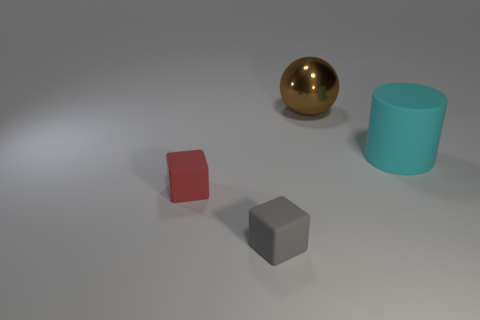Subtract all red blocks. How many blocks are left? 1 Subtract 1 cylinders. How many cylinders are left? 0 Subtract all red blocks. How many red cylinders are left? 0 Add 2 cyan rubber cylinders. How many cyan rubber cylinders are left? 3 Add 3 tiny gray rubber blocks. How many tiny gray rubber blocks exist? 4 Add 4 brown balls. How many objects exist? 8 Subtract 1 gray cubes. How many objects are left? 3 Subtract all purple cubes. Subtract all gray spheres. How many cubes are left? 2 Subtract all large cylinders. Subtract all small rubber objects. How many objects are left? 1 